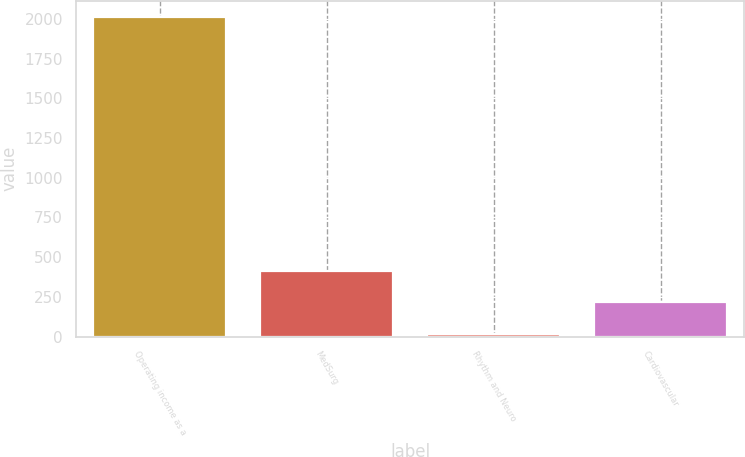Convert chart to OTSL. <chart><loc_0><loc_0><loc_500><loc_500><bar_chart><fcel>Operating income as a<fcel>MedSurg<fcel>Rhythm and Neuro<fcel>Cardiovascular<nl><fcel>2016<fcel>415.36<fcel>15.2<fcel>215.28<nl></chart> 